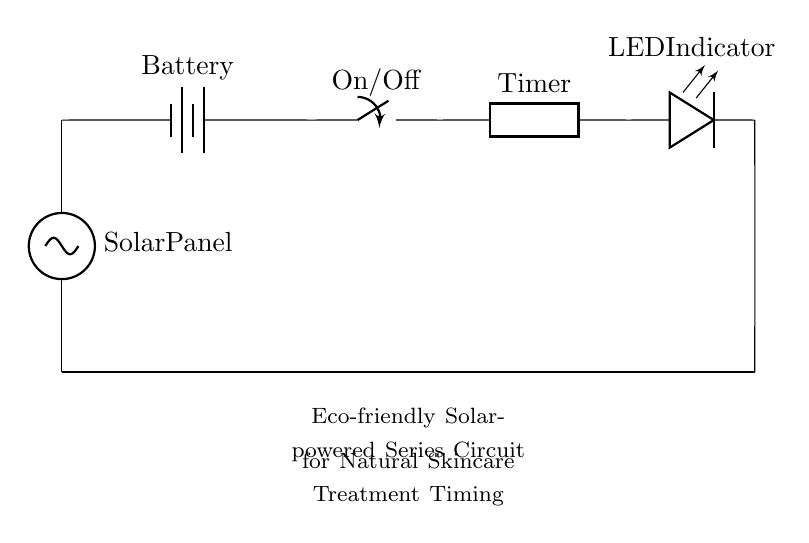What is the main power source of this circuit? The main power source is a solar panel, which converts sunlight into electrical energy, as indicated at the start of the circuit diagram.
Answer: solar panel What component indicates the circuit is powered on? The LED indicates the circuit is powered on, as it glows when current flows through this part of the circuit.
Answer: LED How many total components are in the circuit? There are five components in total: solar panel, battery, switch, timer, and LED.
Answer: five What does the timer in the circuit control? The timer controls the duration for which the skincare treatment should be applied, suggesting it determines the on-time for the circuit operations.
Answer: duration What type of circuit is represented? This is a series circuit, as all components are connected end-to-end, sharing the same current pathway.
Answer: series What happens when the switch is in the "off" position? When the switch is off, it breaks the circuit, preventing any current from flowing, and therefore the timer and LED will not function.
Answer: no current Which component stores energy for later use in the circuit? The battery stores energy, providing a reserve of electrical power for the circuit when needed, especially during times when sunlight is not available.
Answer: battery 